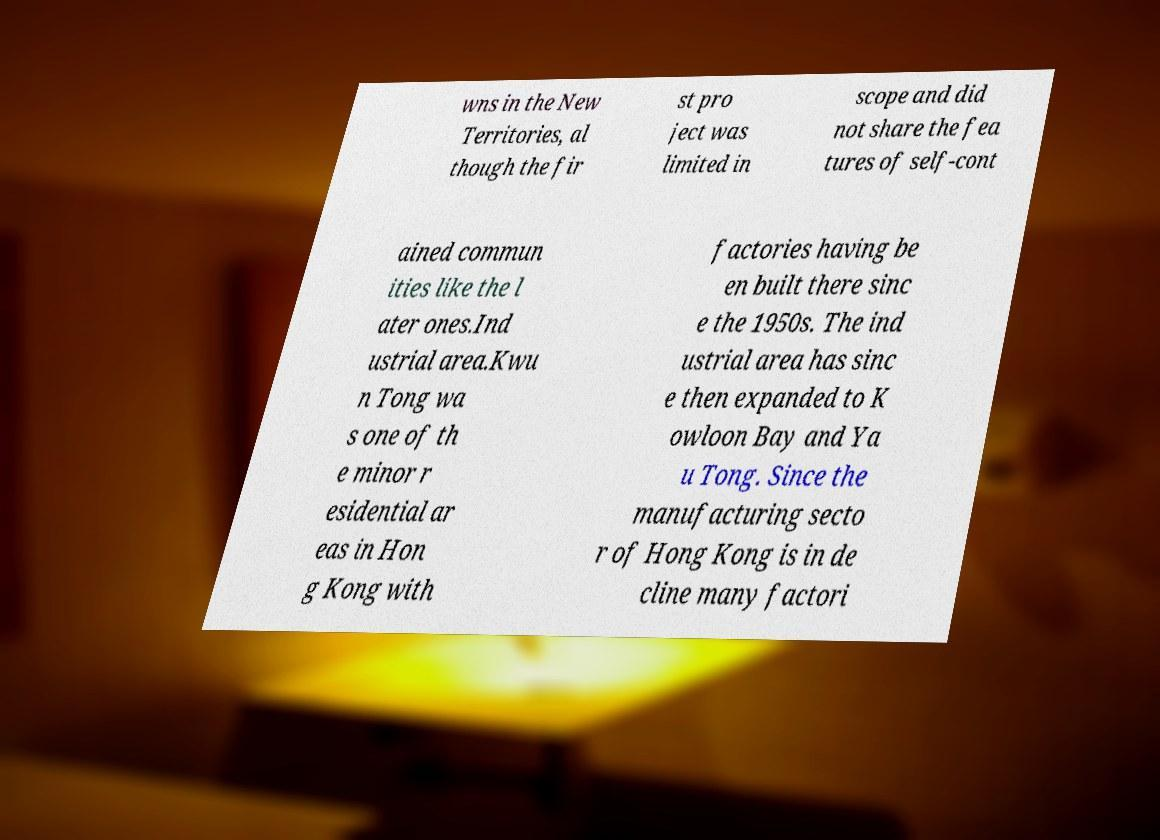Please identify and transcribe the text found in this image. wns in the New Territories, al though the fir st pro ject was limited in scope and did not share the fea tures of self-cont ained commun ities like the l ater ones.Ind ustrial area.Kwu n Tong wa s one of th e minor r esidential ar eas in Hon g Kong with factories having be en built there sinc e the 1950s. The ind ustrial area has sinc e then expanded to K owloon Bay and Ya u Tong. Since the manufacturing secto r of Hong Kong is in de cline many factori 